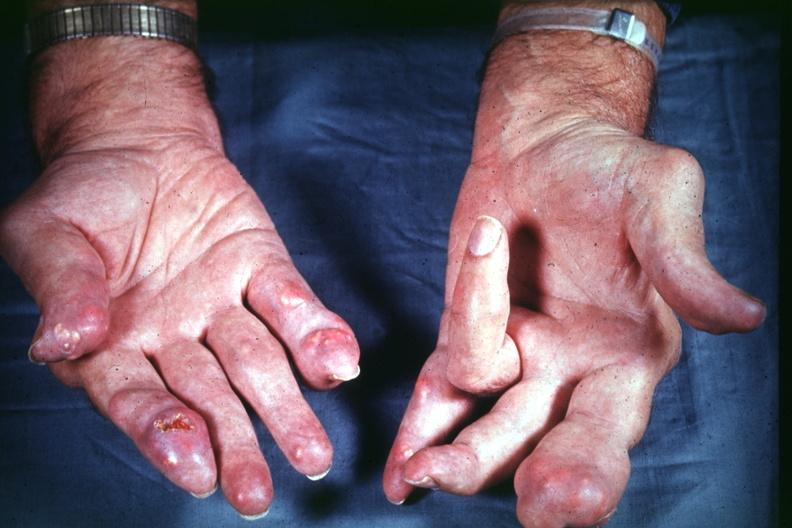re extremities present?
Answer the question using a single word or phrase. Yes 